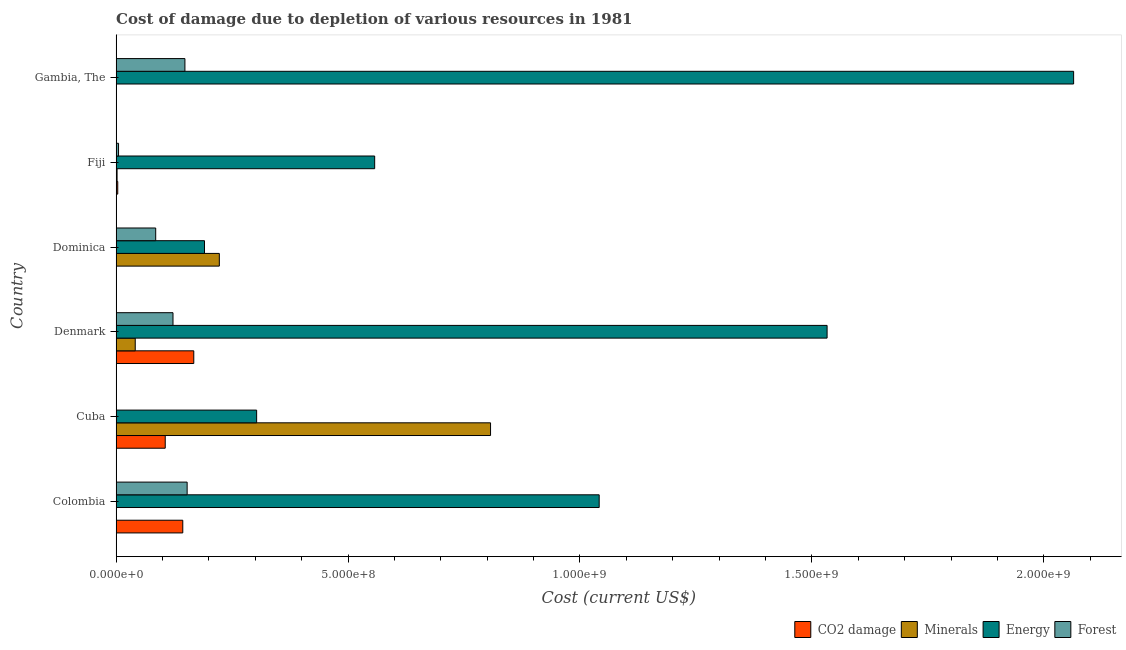How many different coloured bars are there?
Ensure brevity in your answer.  4. How many bars are there on the 6th tick from the bottom?
Provide a short and direct response. 4. What is the label of the 3rd group of bars from the top?
Provide a succinct answer. Dominica. In how many cases, is the number of bars for a given country not equal to the number of legend labels?
Give a very brief answer. 0. What is the cost of damage due to depletion of minerals in Dominica?
Offer a terse response. 2.22e+08. Across all countries, what is the maximum cost of damage due to depletion of forests?
Offer a terse response. 1.53e+08. Across all countries, what is the minimum cost of damage due to depletion of minerals?
Make the answer very short. 6062.38. In which country was the cost of damage due to depletion of forests maximum?
Offer a terse response. Colombia. In which country was the cost of damage due to depletion of coal minimum?
Give a very brief answer. Dominica. What is the total cost of damage due to depletion of minerals in the graph?
Ensure brevity in your answer.  1.07e+09. What is the difference between the cost of damage due to depletion of minerals in Fiji and that in Gambia, The?
Ensure brevity in your answer.  1.69e+06. What is the difference between the cost of damage due to depletion of minerals in Fiji and the cost of damage due to depletion of forests in Colombia?
Offer a very short reply. -1.51e+08. What is the average cost of damage due to depletion of coal per country?
Offer a terse response. 7.02e+07. What is the difference between the cost of damage due to depletion of coal and cost of damage due to depletion of energy in Denmark?
Your answer should be very brief. -1.37e+09. In how many countries, is the cost of damage due to depletion of coal greater than 600000000 US$?
Provide a succinct answer. 0. What is the ratio of the cost of damage due to depletion of coal in Cuba to that in Dominica?
Give a very brief answer. 893.1. What is the difference between the highest and the second highest cost of damage due to depletion of minerals?
Ensure brevity in your answer.  5.85e+08. What is the difference between the highest and the lowest cost of damage due to depletion of energy?
Keep it short and to the point. 1.87e+09. Is the sum of the cost of damage due to depletion of minerals in Cuba and Denmark greater than the maximum cost of damage due to depletion of forests across all countries?
Offer a terse response. Yes. What does the 4th bar from the top in Cuba represents?
Give a very brief answer. CO2 damage. What does the 1st bar from the bottom in Cuba represents?
Provide a short and direct response. CO2 damage. Are all the bars in the graph horizontal?
Your response must be concise. Yes. What is the difference between two consecutive major ticks on the X-axis?
Provide a succinct answer. 5.00e+08. Are the values on the major ticks of X-axis written in scientific E-notation?
Give a very brief answer. Yes. Does the graph contain any zero values?
Give a very brief answer. No. Does the graph contain grids?
Your answer should be compact. No. Where does the legend appear in the graph?
Keep it short and to the point. Bottom right. How many legend labels are there?
Your answer should be very brief. 4. How are the legend labels stacked?
Provide a short and direct response. Horizontal. What is the title of the graph?
Make the answer very short. Cost of damage due to depletion of various resources in 1981 . What is the label or title of the X-axis?
Your answer should be compact. Cost (current US$). What is the label or title of the Y-axis?
Offer a terse response. Country. What is the Cost (current US$) in CO2 damage in Colombia?
Provide a succinct answer. 1.44e+08. What is the Cost (current US$) in Minerals in Colombia?
Your answer should be very brief. 6062.38. What is the Cost (current US$) of Energy in Colombia?
Offer a terse response. 1.04e+09. What is the Cost (current US$) of Forest in Colombia?
Give a very brief answer. 1.53e+08. What is the Cost (current US$) of CO2 damage in Cuba?
Offer a very short reply. 1.06e+08. What is the Cost (current US$) of Minerals in Cuba?
Give a very brief answer. 8.07e+08. What is the Cost (current US$) in Energy in Cuba?
Provide a succinct answer. 3.03e+08. What is the Cost (current US$) of Forest in Cuba?
Provide a succinct answer. 2.40e+05. What is the Cost (current US$) of CO2 damage in Denmark?
Provide a short and direct response. 1.67e+08. What is the Cost (current US$) in Minerals in Denmark?
Ensure brevity in your answer.  4.12e+07. What is the Cost (current US$) in Energy in Denmark?
Your answer should be compact. 1.53e+09. What is the Cost (current US$) in Forest in Denmark?
Give a very brief answer. 1.23e+08. What is the Cost (current US$) in CO2 damage in Dominica?
Provide a short and direct response. 1.19e+05. What is the Cost (current US$) in Minerals in Dominica?
Your answer should be compact. 2.22e+08. What is the Cost (current US$) of Energy in Dominica?
Provide a succinct answer. 1.91e+08. What is the Cost (current US$) in Forest in Dominica?
Your response must be concise. 8.53e+07. What is the Cost (current US$) of CO2 damage in Fiji?
Your answer should be very brief. 3.50e+06. What is the Cost (current US$) of Minerals in Fiji?
Offer a very short reply. 2.03e+06. What is the Cost (current US$) of Energy in Fiji?
Provide a succinct answer. 5.57e+08. What is the Cost (current US$) of Forest in Fiji?
Keep it short and to the point. 5.21e+06. What is the Cost (current US$) in CO2 damage in Gambia, The?
Your answer should be very brief. 5.10e+05. What is the Cost (current US$) of Minerals in Gambia, The?
Your answer should be very brief. 3.46e+05. What is the Cost (current US$) of Energy in Gambia, The?
Provide a succinct answer. 2.06e+09. What is the Cost (current US$) of Forest in Gambia, The?
Your response must be concise. 1.48e+08. Across all countries, what is the maximum Cost (current US$) in CO2 damage?
Provide a short and direct response. 1.67e+08. Across all countries, what is the maximum Cost (current US$) in Minerals?
Offer a very short reply. 8.07e+08. Across all countries, what is the maximum Cost (current US$) in Energy?
Offer a very short reply. 2.06e+09. Across all countries, what is the maximum Cost (current US$) in Forest?
Make the answer very short. 1.53e+08. Across all countries, what is the minimum Cost (current US$) of CO2 damage?
Your answer should be compact. 1.19e+05. Across all countries, what is the minimum Cost (current US$) of Minerals?
Provide a succinct answer. 6062.38. Across all countries, what is the minimum Cost (current US$) of Energy?
Provide a short and direct response. 1.91e+08. Across all countries, what is the minimum Cost (current US$) of Forest?
Your answer should be compact. 2.40e+05. What is the total Cost (current US$) in CO2 damage in the graph?
Your answer should be very brief. 4.21e+08. What is the total Cost (current US$) in Minerals in the graph?
Give a very brief answer. 1.07e+09. What is the total Cost (current US$) in Energy in the graph?
Provide a short and direct response. 5.69e+09. What is the total Cost (current US$) in Forest in the graph?
Your answer should be compact. 5.15e+08. What is the difference between the Cost (current US$) of CO2 damage in Colombia and that in Cuba?
Give a very brief answer. 3.78e+07. What is the difference between the Cost (current US$) of Minerals in Colombia and that in Cuba?
Keep it short and to the point. -8.07e+08. What is the difference between the Cost (current US$) in Energy in Colombia and that in Cuba?
Your response must be concise. 7.39e+08. What is the difference between the Cost (current US$) of Forest in Colombia and that in Cuba?
Your response must be concise. 1.53e+08. What is the difference between the Cost (current US$) in CO2 damage in Colombia and that in Denmark?
Offer a terse response. -2.37e+07. What is the difference between the Cost (current US$) of Minerals in Colombia and that in Denmark?
Provide a short and direct response. -4.12e+07. What is the difference between the Cost (current US$) in Energy in Colombia and that in Denmark?
Ensure brevity in your answer.  -4.91e+08. What is the difference between the Cost (current US$) of Forest in Colombia and that in Denmark?
Your response must be concise. 3.05e+07. What is the difference between the Cost (current US$) of CO2 damage in Colombia and that in Dominica?
Your response must be concise. 1.44e+08. What is the difference between the Cost (current US$) in Minerals in Colombia and that in Dominica?
Offer a terse response. -2.22e+08. What is the difference between the Cost (current US$) in Energy in Colombia and that in Dominica?
Your response must be concise. 8.51e+08. What is the difference between the Cost (current US$) of Forest in Colombia and that in Dominica?
Your response must be concise. 6.78e+07. What is the difference between the Cost (current US$) of CO2 damage in Colombia and that in Fiji?
Your answer should be very brief. 1.40e+08. What is the difference between the Cost (current US$) in Minerals in Colombia and that in Fiji?
Your answer should be compact. -2.03e+06. What is the difference between the Cost (current US$) of Energy in Colombia and that in Fiji?
Your answer should be compact. 4.84e+08. What is the difference between the Cost (current US$) in Forest in Colombia and that in Fiji?
Provide a succinct answer. 1.48e+08. What is the difference between the Cost (current US$) of CO2 damage in Colombia and that in Gambia, The?
Ensure brevity in your answer.  1.43e+08. What is the difference between the Cost (current US$) of Minerals in Colombia and that in Gambia, The?
Offer a very short reply. -3.40e+05. What is the difference between the Cost (current US$) in Energy in Colombia and that in Gambia, The?
Offer a terse response. -1.02e+09. What is the difference between the Cost (current US$) of Forest in Colombia and that in Gambia, The?
Offer a terse response. 4.76e+06. What is the difference between the Cost (current US$) of CO2 damage in Cuba and that in Denmark?
Ensure brevity in your answer.  -6.15e+07. What is the difference between the Cost (current US$) of Minerals in Cuba and that in Denmark?
Provide a succinct answer. 7.66e+08. What is the difference between the Cost (current US$) of Energy in Cuba and that in Denmark?
Offer a terse response. -1.23e+09. What is the difference between the Cost (current US$) of Forest in Cuba and that in Denmark?
Provide a short and direct response. -1.22e+08. What is the difference between the Cost (current US$) in CO2 damage in Cuba and that in Dominica?
Your answer should be compact. 1.06e+08. What is the difference between the Cost (current US$) in Minerals in Cuba and that in Dominica?
Your answer should be very brief. 5.85e+08. What is the difference between the Cost (current US$) in Energy in Cuba and that in Dominica?
Make the answer very short. 1.12e+08. What is the difference between the Cost (current US$) of Forest in Cuba and that in Dominica?
Provide a short and direct response. -8.51e+07. What is the difference between the Cost (current US$) of CO2 damage in Cuba and that in Fiji?
Provide a succinct answer. 1.02e+08. What is the difference between the Cost (current US$) of Minerals in Cuba and that in Fiji?
Give a very brief answer. 8.05e+08. What is the difference between the Cost (current US$) in Energy in Cuba and that in Fiji?
Make the answer very short. -2.54e+08. What is the difference between the Cost (current US$) in Forest in Cuba and that in Fiji?
Provide a succinct answer. -4.97e+06. What is the difference between the Cost (current US$) of CO2 damage in Cuba and that in Gambia, The?
Your answer should be compact. 1.05e+08. What is the difference between the Cost (current US$) in Minerals in Cuba and that in Gambia, The?
Provide a succinct answer. 8.07e+08. What is the difference between the Cost (current US$) of Energy in Cuba and that in Gambia, The?
Your response must be concise. -1.76e+09. What is the difference between the Cost (current US$) of Forest in Cuba and that in Gambia, The?
Provide a succinct answer. -1.48e+08. What is the difference between the Cost (current US$) of CO2 damage in Denmark and that in Dominica?
Offer a terse response. 1.67e+08. What is the difference between the Cost (current US$) in Minerals in Denmark and that in Dominica?
Your answer should be very brief. -1.81e+08. What is the difference between the Cost (current US$) in Energy in Denmark and that in Dominica?
Offer a very short reply. 1.34e+09. What is the difference between the Cost (current US$) in Forest in Denmark and that in Dominica?
Give a very brief answer. 3.73e+07. What is the difference between the Cost (current US$) of CO2 damage in Denmark and that in Fiji?
Provide a short and direct response. 1.64e+08. What is the difference between the Cost (current US$) in Minerals in Denmark and that in Fiji?
Give a very brief answer. 3.92e+07. What is the difference between the Cost (current US$) of Energy in Denmark and that in Fiji?
Provide a short and direct response. 9.75e+08. What is the difference between the Cost (current US$) in Forest in Denmark and that in Fiji?
Your answer should be very brief. 1.17e+08. What is the difference between the Cost (current US$) of CO2 damage in Denmark and that in Gambia, The?
Give a very brief answer. 1.67e+08. What is the difference between the Cost (current US$) in Minerals in Denmark and that in Gambia, The?
Offer a terse response. 4.09e+07. What is the difference between the Cost (current US$) in Energy in Denmark and that in Gambia, The?
Offer a terse response. -5.31e+08. What is the difference between the Cost (current US$) of Forest in Denmark and that in Gambia, The?
Keep it short and to the point. -2.57e+07. What is the difference between the Cost (current US$) in CO2 damage in Dominica and that in Fiji?
Ensure brevity in your answer.  -3.38e+06. What is the difference between the Cost (current US$) of Minerals in Dominica and that in Fiji?
Your answer should be compact. 2.20e+08. What is the difference between the Cost (current US$) of Energy in Dominica and that in Fiji?
Make the answer very short. -3.67e+08. What is the difference between the Cost (current US$) in Forest in Dominica and that in Fiji?
Your answer should be very brief. 8.01e+07. What is the difference between the Cost (current US$) in CO2 damage in Dominica and that in Gambia, The?
Keep it short and to the point. -3.91e+05. What is the difference between the Cost (current US$) of Minerals in Dominica and that in Gambia, The?
Ensure brevity in your answer.  2.22e+08. What is the difference between the Cost (current US$) in Energy in Dominica and that in Gambia, The?
Your answer should be compact. -1.87e+09. What is the difference between the Cost (current US$) of Forest in Dominica and that in Gambia, The?
Offer a very short reply. -6.30e+07. What is the difference between the Cost (current US$) in CO2 damage in Fiji and that in Gambia, The?
Give a very brief answer. 2.99e+06. What is the difference between the Cost (current US$) of Minerals in Fiji and that in Gambia, The?
Ensure brevity in your answer.  1.69e+06. What is the difference between the Cost (current US$) of Energy in Fiji and that in Gambia, The?
Provide a succinct answer. -1.51e+09. What is the difference between the Cost (current US$) of Forest in Fiji and that in Gambia, The?
Make the answer very short. -1.43e+08. What is the difference between the Cost (current US$) in CO2 damage in Colombia and the Cost (current US$) in Minerals in Cuba?
Make the answer very short. -6.64e+08. What is the difference between the Cost (current US$) of CO2 damage in Colombia and the Cost (current US$) of Energy in Cuba?
Keep it short and to the point. -1.59e+08. What is the difference between the Cost (current US$) of CO2 damage in Colombia and the Cost (current US$) of Forest in Cuba?
Offer a very short reply. 1.43e+08. What is the difference between the Cost (current US$) in Minerals in Colombia and the Cost (current US$) in Energy in Cuba?
Make the answer very short. -3.03e+08. What is the difference between the Cost (current US$) of Minerals in Colombia and the Cost (current US$) of Forest in Cuba?
Offer a very short reply. -2.34e+05. What is the difference between the Cost (current US$) of Energy in Colombia and the Cost (current US$) of Forest in Cuba?
Your answer should be very brief. 1.04e+09. What is the difference between the Cost (current US$) in CO2 damage in Colombia and the Cost (current US$) in Minerals in Denmark?
Give a very brief answer. 1.03e+08. What is the difference between the Cost (current US$) of CO2 damage in Colombia and the Cost (current US$) of Energy in Denmark?
Provide a short and direct response. -1.39e+09. What is the difference between the Cost (current US$) in CO2 damage in Colombia and the Cost (current US$) in Forest in Denmark?
Provide a succinct answer. 2.11e+07. What is the difference between the Cost (current US$) of Minerals in Colombia and the Cost (current US$) of Energy in Denmark?
Offer a terse response. -1.53e+09. What is the difference between the Cost (current US$) in Minerals in Colombia and the Cost (current US$) in Forest in Denmark?
Make the answer very short. -1.23e+08. What is the difference between the Cost (current US$) of Energy in Colombia and the Cost (current US$) of Forest in Denmark?
Offer a terse response. 9.19e+08. What is the difference between the Cost (current US$) in CO2 damage in Colombia and the Cost (current US$) in Minerals in Dominica?
Provide a succinct answer. -7.88e+07. What is the difference between the Cost (current US$) of CO2 damage in Colombia and the Cost (current US$) of Energy in Dominica?
Your answer should be compact. -4.68e+07. What is the difference between the Cost (current US$) of CO2 damage in Colombia and the Cost (current US$) of Forest in Dominica?
Offer a terse response. 5.84e+07. What is the difference between the Cost (current US$) in Minerals in Colombia and the Cost (current US$) in Energy in Dominica?
Keep it short and to the point. -1.90e+08. What is the difference between the Cost (current US$) in Minerals in Colombia and the Cost (current US$) in Forest in Dominica?
Give a very brief answer. -8.53e+07. What is the difference between the Cost (current US$) of Energy in Colombia and the Cost (current US$) of Forest in Dominica?
Provide a short and direct response. 9.56e+08. What is the difference between the Cost (current US$) of CO2 damage in Colombia and the Cost (current US$) of Minerals in Fiji?
Your response must be concise. 1.42e+08. What is the difference between the Cost (current US$) in CO2 damage in Colombia and the Cost (current US$) in Energy in Fiji?
Give a very brief answer. -4.14e+08. What is the difference between the Cost (current US$) in CO2 damage in Colombia and the Cost (current US$) in Forest in Fiji?
Give a very brief answer. 1.38e+08. What is the difference between the Cost (current US$) of Minerals in Colombia and the Cost (current US$) of Energy in Fiji?
Offer a very short reply. -5.57e+08. What is the difference between the Cost (current US$) in Minerals in Colombia and the Cost (current US$) in Forest in Fiji?
Make the answer very short. -5.20e+06. What is the difference between the Cost (current US$) of Energy in Colombia and the Cost (current US$) of Forest in Fiji?
Offer a terse response. 1.04e+09. What is the difference between the Cost (current US$) of CO2 damage in Colombia and the Cost (current US$) of Minerals in Gambia, The?
Keep it short and to the point. 1.43e+08. What is the difference between the Cost (current US$) in CO2 damage in Colombia and the Cost (current US$) in Energy in Gambia, The?
Provide a short and direct response. -1.92e+09. What is the difference between the Cost (current US$) of CO2 damage in Colombia and the Cost (current US$) of Forest in Gambia, The?
Keep it short and to the point. -4.62e+06. What is the difference between the Cost (current US$) of Minerals in Colombia and the Cost (current US$) of Energy in Gambia, The?
Offer a very short reply. -2.06e+09. What is the difference between the Cost (current US$) of Minerals in Colombia and the Cost (current US$) of Forest in Gambia, The?
Keep it short and to the point. -1.48e+08. What is the difference between the Cost (current US$) in Energy in Colombia and the Cost (current US$) in Forest in Gambia, The?
Provide a succinct answer. 8.93e+08. What is the difference between the Cost (current US$) of CO2 damage in Cuba and the Cost (current US$) of Minerals in Denmark?
Your answer should be compact. 6.47e+07. What is the difference between the Cost (current US$) in CO2 damage in Cuba and the Cost (current US$) in Energy in Denmark?
Offer a very short reply. -1.43e+09. What is the difference between the Cost (current US$) in CO2 damage in Cuba and the Cost (current US$) in Forest in Denmark?
Offer a terse response. -1.68e+07. What is the difference between the Cost (current US$) in Minerals in Cuba and the Cost (current US$) in Energy in Denmark?
Your response must be concise. -7.26e+08. What is the difference between the Cost (current US$) in Minerals in Cuba and the Cost (current US$) in Forest in Denmark?
Your answer should be compact. 6.85e+08. What is the difference between the Cost (current US$) of Energy in Cuba and the Cost (current US$) of Forest in Denmark?
Provide a succinct answer. 1.80e+08. What is the difference between the Cost (current US$) of CO2 damage in Cuba and the Cost (current US$) of Minerals in Dominica?
Offer a very short reply. -1.17e+08. What is the difference between the Cost (current US$) of CO2 damage in Cuba and the Cost (current US$) of Energy in Dominica?
Keep it short and to the point. -8.46e+07. What is the difference between the Cost (current US$) of CO2 damage in Cuba and the Cost (current US$) of Forest in Dominica?
Keep it short and to the point. 2.05e+07. What is the difference between the Cost (current US$) of Minerals in Cuba and the Cost (current US$) of Energy in Dominica?
Keep it short and to the point. 6.17e+08. What is the difference between the Cost (current US$) of Minerals in Cuba and the Cost (current US$) of Forest in Dominica?
Make the answer very short. 7.22e+08. What is the difference between the Cost (current US$) in Energy in Cuba and the Cost (current US$) in Forest in Dominica?
Give a very brief answer. 2.18e+08. What is the difference between the Cost (current US$) in CO2 damage in Cuba and the Cost (current US$) in Minerals in Fiji?
Provide a succinct answer. 1.04e+08. What is the difference between the Cost (current US$) in CO2 damage in Cuba and the Cost (current US$) in Energy in Fiji?
Provide a succinct answer. -4.52e+08. What is the difference between the Cost (current US$) in CO2 damage in Cuba and the Cost (current US$) in Forest in Fiji?
Ensure brevity in your answer.  1.01e+08. What is the difference between the Cost (current US$) of Minerals in Cuba and the Cost (current US$) of Energy in Fiji?
Offer a very short reply. 2.50e+08. What is the difference between the Cost (current US$) of Minerals in Cuba and the Cost (current US$) of Forest in Fiji?
Keep it short and to the point. 8.02e+08. What is the difference between the Cost (current US$) in Energy in Cuba and the Cost (current US$) in Forest in Fiji?
Offer a very short reply. 2.98e+08. What is the difference between the Cost (current US$) in CO2 damage in Cuba and the Cost (current US$) in Minerals in Gambia, The?
Your response must be concise. 1.06e+08. What is the difference between the Cost (current US$) in CO2 damage in Cuba and the Cost (current US$) in Energy in Gambia, The?
Your answer should be compact. -1.96e+09. What is the difference between the Cost (current US$) of CO2 damage in Cuba and the Cost (current US$) of Forest in Gambia, The?
Your answer should be very brief. -4.25e+07. What is the difference between the Cost (current US$) in Minerals in Cuba and the Cost (current US$) in Energy in Gambia, The?
Give a very brief answer. -1.26e+09. What is the difference between the Cost (current US$) of Minerals in Cuba and the Cost (current US$) of Forest in Gambia, The?
Provide a succinct answer. 6.59e+08. What is the difference between the Cost (current US$) in Energy in Cuba and the Cost (current US$) in Forest in Gambia, The?
Give a very brief answer. 1.55e+08. What is the difference between the Cost (current US$) in CO2 damage in Denmark and the Cost (current US$) in Minerals in Dominica?
Give a very brief answer. -5.51e+07. What is the difference between the Cost (current US$) of CO2 damage in Denmark and the Cost (current US$) of Energy in Dominica?
Offer a very short reply. -2.31e+07. What is the difference between the Cost (current US$) in CO2 damage in Denmark and the Cost (current US$) in Forest in Dominica?
Give a very brief answer. 8.21e+07. What is the difference between the Cost (current US$) in Minerals in Denmark and the Cost (current US$) in Energy in Dominica?
Provide a succinct answer. -1.49e+08. What is the difference between the Cost (current US$) of Minerals in Denmark and the Cost (current US$) of Forest in Dominica?
Ensure brevity in your answer.  -4.41e+07. What is the difference between the Cost (current US$) in Energy in Denmark and the Cost (current US$) in Forest in Dominica?
Give a very brief answer. 1.45e+09. What is the difference between the Cost (current US$) in CO2 damage in Denmark and the Cost (current US$) in Minerals in Fiji?
Offer a very short reply. 1.65e+08. What is the difference between the Cost (current US$) in CO2 damage in Denmark and the Cost (current US$) in Energy in Fiji?
Provide a short and direct response. -3.90e+08. What is the difference between the Cost (current US$) in CO2 damage in Denmark and the Cost (current US$) in Forest in Fiji?
Give a very brief answer. 1.62e+08. What is the difference between the Cost (current US$) in Minerals in Denmark and the Cost (current US$) in Energy in Fiji?
Your response must be concise. -5.16e+08. What is the difference between the Cost (current US$) of Minerals in Denmark and the Cost (current US$) of Forest in Fiji?
Your answer should be compact. 3.60e+07. What is the difference between the Cost (current US$) of Energy in Denmark and the Cost (current US$) of Forest in Fiji?
Your answer should be very brief. 1.53e+09. What is the difference between the Cost (current US$) of CO2 damage in Denmark and the Cost (current US$) of Minerals in Gambia, The?
Provide a short and direct response. 1.67e+08. What is the difference between the Cost (current US$) of CO2 damage in Denmark and the Cost (current US$) of Energy in Gambia, The?
Make the answer very short. -1.90e+09. What is the difference between the Cost (current US$) in CO2 damage in Denmark and the Cost (current US$) in Forest in Gambia, The?
Your response must be concise. 1.91e+07. What is the difference between the Cost (current US$) of Minerals in Denmark and the Cost (current US$) of Energy in Gambia, The?
Ensure brevity in your answer.  -2.02e+09. What is the difference between the Cost (current US$) in Minerals in Denmark and the Cost (current US$) in Forest in Gambia, The?
Offer a terse response. -1.07e+08. What is the difference between the Cost (current US$) in Energy in Denmark and the Cost (current US$) in Forest in Gambia, The?
Provide a short and direct response. 1.38e+09. What is the difference between the Cost (current US$) of CO2 damage in Dominica and the Cost (current US$) of Minerals in Fiji?
Your answer should be compact. -1.92e+06. What is the difference between the Cost (current US$) in CO2 damage in Dominica and the Cost (current US$) in Energy in Fiji?
Your response must be concise. -5.57e+08. What is the difference between the Cost (current US$) of CO2 damage in Dominica and the Cost (current US$) of Forest in Fiji?
Your answer should be very brief. -5.09e+06. What is the difference between the Cost (current US$) in Minerals in Dominica and the Cost (current US$) in Energy in Fiji?
Give a very brief answer. -3.35e+08. What is the difference between the Cost (current US$) in Minerals in Dominica and the Cost (current US$) in Forest in Fiji?
Make the answer very short. 2.17e+08. What is the difference between the Cost (current US$) of Energy in Dominica and the Cost (current US$) of Forest in Fiji?
Your answer should be very brief. 1.85e+08. What is the difference between the Cost (current US$) of CO2 damage in Dominica and the Cost (current US$) of Minerals in Gambia, The?
Your response must be concise. -2.28e+05. What is the difference between the Cost (current US$) of CO2 damage in Dominica and the Cost (current US$) of Energy in Gambia, The?
Offer a terse response. -2.06e+09. What is the difference between the Cost (current US$) in CO2 damage in Dominica and the Cost (current US$) in Forest in Gambia, The?
Offer a terse response. -1.48e+08. What is the difference between the Cost (current US$) of Minerals in Dominica and the Cost (current US$) of Energy in Gambia, The?
Your answer should be compact. -1.84e+09. What is the difference between the Cost (current US$) in Minerals in Dominica and the Cost (current US$) in Forest in Gambia, The?
Make the answer very short. 7.41e+07. What is the difference between the Cost (current US$) in Energy in Dominica and the Cost (current US$) in Forest in Gambia, The?
Provide a succinct answer. 4.22e+07. What is the difference between the Cost (current US$) of CO2 damage in Fiji and the Cost (current US$) of Minerals in Gambia, The?
Offer a very short reply. 3.15e+06. What is the difference between the Cost (current US$) in CO2 damage in Fiji and the Cost (current US$) in Energy in Gambia, The?
Ensure brevity in your answer.  -2.06e+09. What is the difference between the Cost (current US$) of CO2 damage in Fiji and the Cost (current US$) of Forest in Gambia, The?
Offer a terse response. -1.45e+08. What is the difference between the Cost (current US$) in Minerals in Fiji and the Cost (current US$) in Energy in Gambia, The?
Your answer should be very brief. -2.06e+09. What is the difference between the Cost (current US$) in Minerals in Fiji and the Cost (current US$) in Forest in Gambia, The?
Ensure brevity in your answer.  -1.46e+08. What is the difference between the Cost (current US$) in Energy in Fiji and the Cost (current US$) in Forest in Gambia, The?
Provide a short and direct response. 4.09e+08. What is the average Cost (current US$) of CO2 damage per country?
Your answer should be very brief. 7.02e+07. What is the average Cost (current US$) in Minerals per country?
Your answer should be very brief. 1.79e+08. What is the average Cost (current US$) of Energy per country?
Give a very brief answer. 9.48e+08. What is the average Cost (current US$) in Forest per country?
Give a very brief answer. 8.58e+07. What is the difference between the Cost (current US$) of CO2 damage and Cost (current US$) of Minerals in Colombia?
Give a very brief answer. 1.44e+08. What is the difference between the Cost (current US$) of CO2 damage and Cost (current US$) of Energy in Colombia?
Provide a short and direct response. -8.98e+08. What is the difference between the Cost (current US$) of CO2 damage and Cost (current US$) of Forest in Colombia?
Keep it short and to the point. -9.39e+06. What is the difference between the Cost (current US$) of Minerals and Cost (current US$) of Energy in Colombia?
Your answer should be compact. -1.04e+09. What is the difference between the Cost (current US$) in Minerals and Cost (current US$) in Forest in Colombia?
Ensure brevity in your answer.  -1.53e+08. What is the difference between the Cost (current US$) of Energy and Cost (current US$) of Forest in Colombia?
Ensure brevity in your answer.  8.88e+08. What is the difference between the Cost (current US$) in CO2 damage and Cost (current US$) in Minerals in Cuba?
Give a very brief answer. -7.01e+08. What is the difference between the Cost (current US$) in CO2 damage and Cost (current US$) in Energy in Cuba?
Your answer should be compact. -1.97e+08. What is the difference between the Cost (current US$) of CO2 damage and Cost (current US$) of Forest in Cuba?
Offer a very short reply. 1.06e+08. What is the difference between the Cost (current US$) of Minerals and Cost (current US$) of Energy in Cuba?
Offer a terse response. 5.04e+08. What is the difference between the Cost (current US$) of Minerals and Cost (current US$) of Forest in Cuba?
Keep it short and to the point. 8.07e+08. What is the difference between the Cost (current US$) of Energy and Cost (current US$) of Forest in Cuba?
Offer a terse response. 3.03e+08. What is the difference between the Cost (current US$) of CO2 damage and Cost (current US$) of Minerals in Denmark?
Offer a terse response. 1.26e+08. What is the difference between the Cost (current US$) of CO2 damage and Cost (current US$) of Energy in Denmark?
Give a very brief answer. -1.37e+09. What is the difference between the Cost (current US$) in CO2 damage and Cost (current US$) in Forest in Denmark?
Provide a succinct answer. 4.48e+07. What is the difference between the Cost (current US$) of Minerals and Cost (current US$) of Energy in Denmark?
Ensure brevity in your answer.  -1.49e+09. What is the difference between the Cost (current US$) of Minerals and Cost (current US$) of Forest in Denmark?
Your answer should be compact. -8.14e+07. What is the difference between the Cost (current US$) of Energy and Cost (current US$) of Forest in Denmark?
Keep it short and to the point. 1.41e+09. What is the difference between the Cost (current US$) in CO2 damage and Cost (current US$) in Minerals in Dominica?
Make the answer very short. -2.22e+08. What is the difference between the Cost (current US$) of CO2 damage and Cost (current US$) of Energy in Dominica?
Give a very brief answer. -1.90e+08. What is the difference between the Cost (current US$) of CO2 damage and Cost (current US$) of Forest in Dominica?
Your answer should be compact. -8.52e+07. What is the difference between the Cost (current US$) of Minerals and Cost (current US$) of Energy in Dominica?
Your answer should be very brief. 3.20e+07. What is the difference between the Cost (current US$) of Minerals and Cost (current US$) of Forest in Dominica?
Provide a succinct answer. 1.37e+08. What is the difference between the Cost (current US$) of Energy and Cost (current US$) of Forest in Dominica?
Your answer should be very brief. 1.05e+08. What is the difference between the Cost (current US$) in CO2 damage and Cost (current US$) in Minerals in Fiji?
Offer a terse response. 1.46e+06. What is the difference between the Cost (current US$) of CO2 damage and Cost (current US$) of Energy in Fiji?
Your response must be concise. -5.54e+08. What is the difference between the Cost (current US$) in CO2 damage and Cost (current US$) in Forest in Fiji?
Make the answer very short. -1.71e+06. What is the difference between the Cost (current US$) in Minerals and Cost (current US$) in Energy in Fiji?
Your answer should be compact. -5.55e+08. What is the difference between the Cost (current US$) of Minerals and Cost (current US$) of Forest in Fiji?
Your answer should be compact. -3.18e+06. What is the difference between the Cost (current US$) in Energy and Cost (current US$) in Forest in Fiji?
Keep it short and to the point. 5.52e+08. What is the difference between the Cost (current US$) in CO2 damage and Cost (current US$) in Minerals in Gambia, The?
Your answer should be compact. 1.64e+05. What is the difference between the Cost (current US$) in CO2 damage and Cost (current US$) in Energy in Gambia, The?
Your answer should be compact. -2.06e+09. What is the difference between the Cost (current US$) of CO2 damage and Cost (current US$) of Forest in Gambia, The?
Your response must be concise. -1.48e+08. What is the difference between the Cost (current US$) in Minerals and Cost (current US$) in Energy in Gambia, The?
Keep it short and to the point. -2.06e+09. What is the difference between the Cost (current US$) in Minerals and Cost (current US$) in Forest in Gambia, The?
Ensure brevity in your answer.  -1.48e+08. What is the difference between the Cost (current US$) of Energy and Cost (current US$) of Forest in Gambia, The?
Your response must be concise. 1.92e+09. What is the ratio of the Cost (current US$) of CO2 damage in Colombia to that in Cuba?
Keep it short and to the point. 1.36. What is the ratio of the Cost (current US$) in Minerals in Colombia to that in Cuba?
Make the answer very short. 0. What is the ratio of the Cost (current US$) of Energy in Colombia to that in Cuba?
Your answer should be compact. 3.44. What is the ratio of the Cost (current US$) in Forest in Colombia to that in Cuba?
Offer a very short reply. 638.44. What is the ratio of the Cost (current US$) of CO2 damage in Colombia to that in Denmark?
Keep it short and to the point. 0.86. What is the ratio of the Cost (current US$) of Energy in Colombia to that in Denmark?
Offer a very short reply. 0.68. What is the ratio of the Cost (current US$) in Forest in Colombia to that in Denmark?
Keep it short and to the point. 1.25. What is the ratio of the Cost (current US$) of CO2 damage in Colombia to that in Dominica?
Offer a very short reply. 1212.4. What is the ratio of the Cost (current US$) in Energy in Colombia to that in Dominica?
Offer a very short reply. 5.47. What is the ratio of the Cost (current US$) in Forest in Colombia to that in Dominica?
Provide a short and direct response. 1.79. What is the ratio of the Cost (current US$) in CO2 damage in Colombia to that in Fiji?
Your answer should be very brief. 41.1. What is the ratio of the Cost (current US$) in Minerals in Colombia to that in Fiji?
Your answer should be compact. 0. What is the ratio of the Cost (current US$) of Energy in Colombia to that in Fiji?
Your answer should be very brief. 1.87. What is the ratio of the Cost (current US$) of Forest in Colombia to that in Fiji?
Your response must be concise. 29.39. What is the ratio of the Cost (current US$) in CO2 damage in Colombia to that in Gambia, The?
Give a very brief answer. 281.95. What is the ratio of the Cost (current US$) of Minerals in Colombia to that in Gambia, The?
Ensure brevity in your answer.  0.02. What is the ratio of the Cost (current US$) of Energy in Colombia to that in Gambia, The?
Provide a short and direct response. 0.5. What is the ratio of the Cost (current US$) of Forest in Colombia to that in Gambia, The?
Your answer should be compact. 1.03. What is the ratio of the Cost (current US$) of CO2 damage in Cuba to that in Denmark?
Offer a very short reply. 0.63. What is the ratio of the Cost (current US$) in Minerals in Cuba to that in Denmark?
Provide a succinct answer. 19.59. What is the ratio of the Cost (current US$) in Energy in Cuba to that in Denmark?
Offer a very short reply. 0.2. What is the ratio of the Cost (current US$) in Forest in Cuba to that in Denmark?
Provide a succinct answer. 0. What is the ratio of the Cost (current US$) in CO2 damage in Cuba to that in Dominica?
Your response must be concise. 893.1. What is the ratio of the Cost (current US$) of Minerals in Cuba to that in Dominica?
Offer a very short reply. 3.63. What is the ratio of the Cost (current US$) of Energy in Cuba to that in Dominica?
Give a very brief answer. 1.59. What is the ratio of the Cost (current US$) of Forest in Cuba to that in Dominica?
Give a very brief answer. 0. What is the ratio of the Cost (current US$) of CO2 damage in Cuba to that in Fiji?
Make the answer very short. 30.27. What is the ratio of the Cost (current US$) of Minerals in Cuba to that in Fiji?
Your answer should be very brief. 396.95. What is the ratio of the Cost (current US$) in Energy in Cuba to that in Fiji?
Make the answer very short. 0.54. What is the ratio of the Cost (current US$) in Forest in Cuba to that in Fiji?
Keep it short and to the point. 0.05. What is the ratio of the Cost (current US$) in CO2 damage in Cuba to that in Gambia, The?
Provide a short and direct response. 207.7. What is the ratio of the Cost (current US$) in Minerals in Cuba to that in Gambia, The?
Provide a short and direct response. 2332.29. What is the ratio of the Cost (current US$) of Energy in Cuba to that in Gambia, The?
Provide a short and direct response. 0.15. What is the ratio of the Cost (current US$) of Forest in Cuba to that in Gambia, The?
Provide a short and direct response. 0. What is the ratio of the Cost (current US$) of CO2 damage in Denmark to that in Dominica?
Provide a short and direct response. 1412.3. What is the ratio of the Cost (current US$) of Minerals in Denmark to that in Dominica?
Offer a very short reply. 0.19. What is the ratio of the Cost (current US$) in Energy in Denmark to that in Dominica?
Ensure brevity in your answer.  8.05. What is the ratio of the Cost (current US$) in Forest in Denmark to that in Dominica?
Give a very brief answer. 1.44. What is the ratio of the Cost (current US$) in CO2 damage in Denmark to that in Fiji?
Keep it short and to the point. 47.87. What is the ratio of the Cost (current US$) in Minerals in Denmark to that in Fiji?
Keep it short and to the point. 20.26. What is the ratio of the Cost (current US$) of Energy in Denmark to that in Fiji?
Your answer should be compact. 2.75. What is the ratio of the Cost (current US$) in Forest in Denmark to that in Fiji?
Provide a short and direct response. 23.54. What is the ratio of the Cost (current US$) in CO2 damage in Denmark to that in Gambia, The?
Provide a short and direct response. 328.44. What is the ratio of the Cost (current US$) in Minerals in Denmark to that in Gambia, The?
Provide a succinct answer. 119.03. What is the ratio of the Cost (current US$) in Energy in Denmark to that in Gambia, The?
Make the answer very short. 0.74. What is the ratio of the Cost (current US$) in Forest in Denmark to that in Gambia, The?
Your response must be concise. 0.83. What is the ratio of the Cost (current US$) in CO2 damage in Dominica to that in Fiji?
Your answer should be very brief. 0.03. What is the ratio of the Cost (current US$) of Minerals in Dominica to that in Fiji?
Offer a terse response. 109.4. What is the ratio of the Cost (current US$) in Energy in Dominica to that in Fiji?
Keep it short and to the point. 0.34. What is the ratio of the Cost (current US$) of Forest in Dominica to that in Fiji?
Offer a very short reply. 16.38. What is the ratio of the Cost (current US$) in CO2 damage in Dominica to that in Gambia, The?
Provide a succinct answer. 0.23. What is the ratio of the Cost (current US$) of Minerals in Dominica to that in Gambia, The?
Your answer should be very brief. 642.79. What is the ratio of the Cost (current US$) of Energy in Dominica to that in Gambia, The?
Your answer should be very brief. 0.09. What is the ratio of the Cost (current US$) of Forest in Dominica to that in Gambia, The?
Provide a succinct answer. 0.58. What is the ratio of the Cost (current US$) in CO2 damage in Fiji to that in Gambia, The?
Offer a very short reply. 6.86. What is the ratio of the Cost (current US$) of Minerals in Fiji to that in Gambia, The?
Your response must be concise. 5.88. What is the ratio of the Cost (current US$) in Energy in Fiji to that in Gambia, The?
Ensure brevity in your answer.  0.27. What is the ratio of the Cost (current US$) of Forest in Fiji to that in Gambia, The?
Your answer should be very brief. 0.04. What is the difference between the highest and the second highest Cost (current US$) in CO2 damage?
Provide a succinct answer. 2.37e+07. What is the difference between the highest and the second highest Cost (current US$) of Minerals?
Offer a terse response. 5.85e+08. What is the difference between the highest and the second highest Cost (current US$) in Energy?
Give a very brief answer. 5.31e+08. What is the difference between the highest and the second highest Cost (current US$) of Forest?
Your answer should be very brief. 4.76e+06. What is the difference between the highest and the lowest Cost (current US$) of CO2 damage?
Offer a very short reply. 1.67e+08. What is the difference between the highest and the lowest Cost (current US$) in Minerals?
Provide a short and direct response. 8.07e+08. What is the difference between the highest and the lowest Cost (current US$) in Energy?
Provide a succinct answer. 1.87e+09. What is the difference between the highest and the lowest Cost (current US$) in Forest?
Offer a terse response. 1.53e+08. 